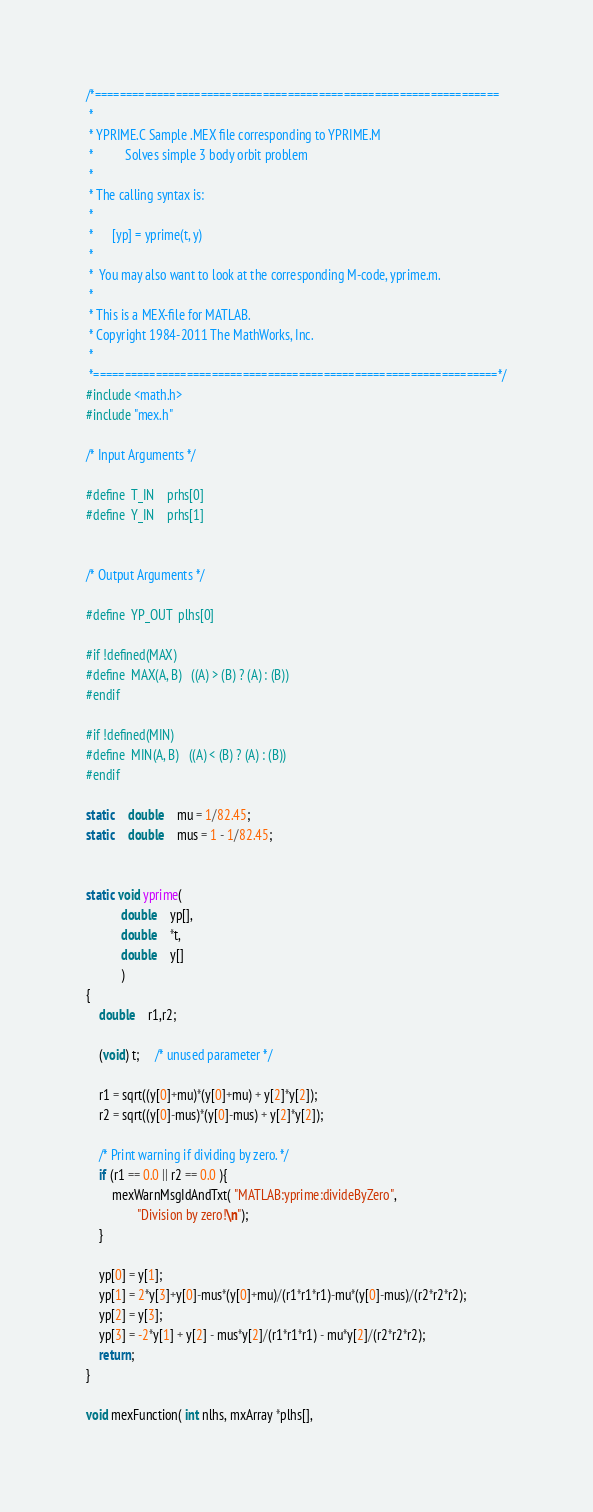Convert code to text. <code><loc_0><loc_0><loc_500><loc_500><_C_>/*=================================================================
 *
 * YPRIME.C	Sample .MEX file corresponding to YPRIME.M
 *	        Solves simple 3 body orbit problem 
 *
 * The calling syntax is:
 *
 *		[yp] = yprime(t, y)
 *
 *  You may also want to look at the corresponding M-code, yprime.m.
 *
 * This is a MEX-file for MATLAB.  
 * Copyright 1984-2011 The MathWorks, Inc.
 *
 *=================================================================*/
#include <math.h>
#include "mex.h"

/* Input Arguments */

#define	T_IN	prhs[0]
#define	Y_IN	prhs[1]


/* Output Arguments */

#define	YP_OUT	plhs[0]

#if !defined(MAX)
#define	MAX(A, B)	((A) > (B) ? (A) : (B))
#endif

#if !defined(MIN)
#define	MIN(A, B)	((A) < (B) ? (A) : (B))
#endif

static	double	mu = 1/82.45;
static	double	mus = 1 - 1/82.45;


static void yprime(
		   double	yp[],
		   double	*t,
 		   double	y[]
		   )
{
    double	r1,r2;
    
    (void) t;     /* unused parameter */

    r1 = sqrt((y[0]+mu)*(y[0]+mu) + y[2]*y[2]); 
    r2 = sqrt((y[0]-mus)*(y[0]-mus) + y[2]*y[2]);

    /* Print warning if dividing by zero. */    
    if (r1 == 0.0 || r2 == 0.0 ){
        mexWarnMsgIdAndTxt( "MATLAB:yprime:divideByZero", 
                "Division by zero!\n");
    }
    
    yp[0] = y[1];
    yp[1] = 2*y[3]+y[0]-mus*(y[0]+mu)/(r1*r1*r1)-mu*(y[0]-mus)/(r2*r2*r2);
    yp[2] = y[3];
    yp[3] = -2*y[1] + y[2] - mus*y[2]/(r1*r1*r1) - mu*y[2]/(r2*r2*r2);
    return;
}

void mexFunction( int nlhs, mxArray *plhs[], </code> 